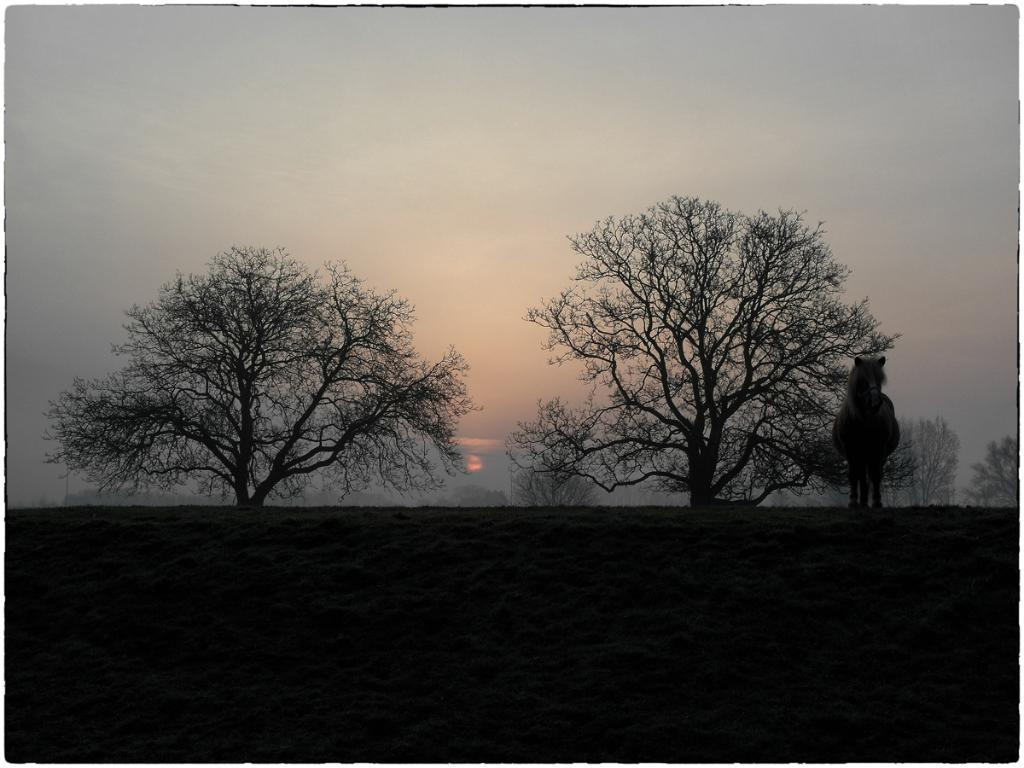What is the main subject in the foreground of the image? There is a horse in the foreground of the image. What is the horse's position in relation to the ground? The horse is standing on the ground. What can be seen in the background of the image? There are trees in the background of the image. What is visible at the top of the image? The sky is visible at the top of the image. What type of environment might the image have been taken in? The image may have been taken in a forest, given the presence of trees in the background. What type of bean is being used as a prop for the horse in the image? There is no bean present in the image, and the horse is not using any props. How many dogs are visible in the image? There are no dogs present in the image; the main subject is a horse. 